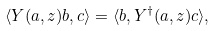<formula> <loc_0><loc_0><loc_500><loc_500>\langle Y ( a , z ) b , c \rangle = \langle b , Y ^ { \dagger } ( a , z ) c \rangle ,</formula> 